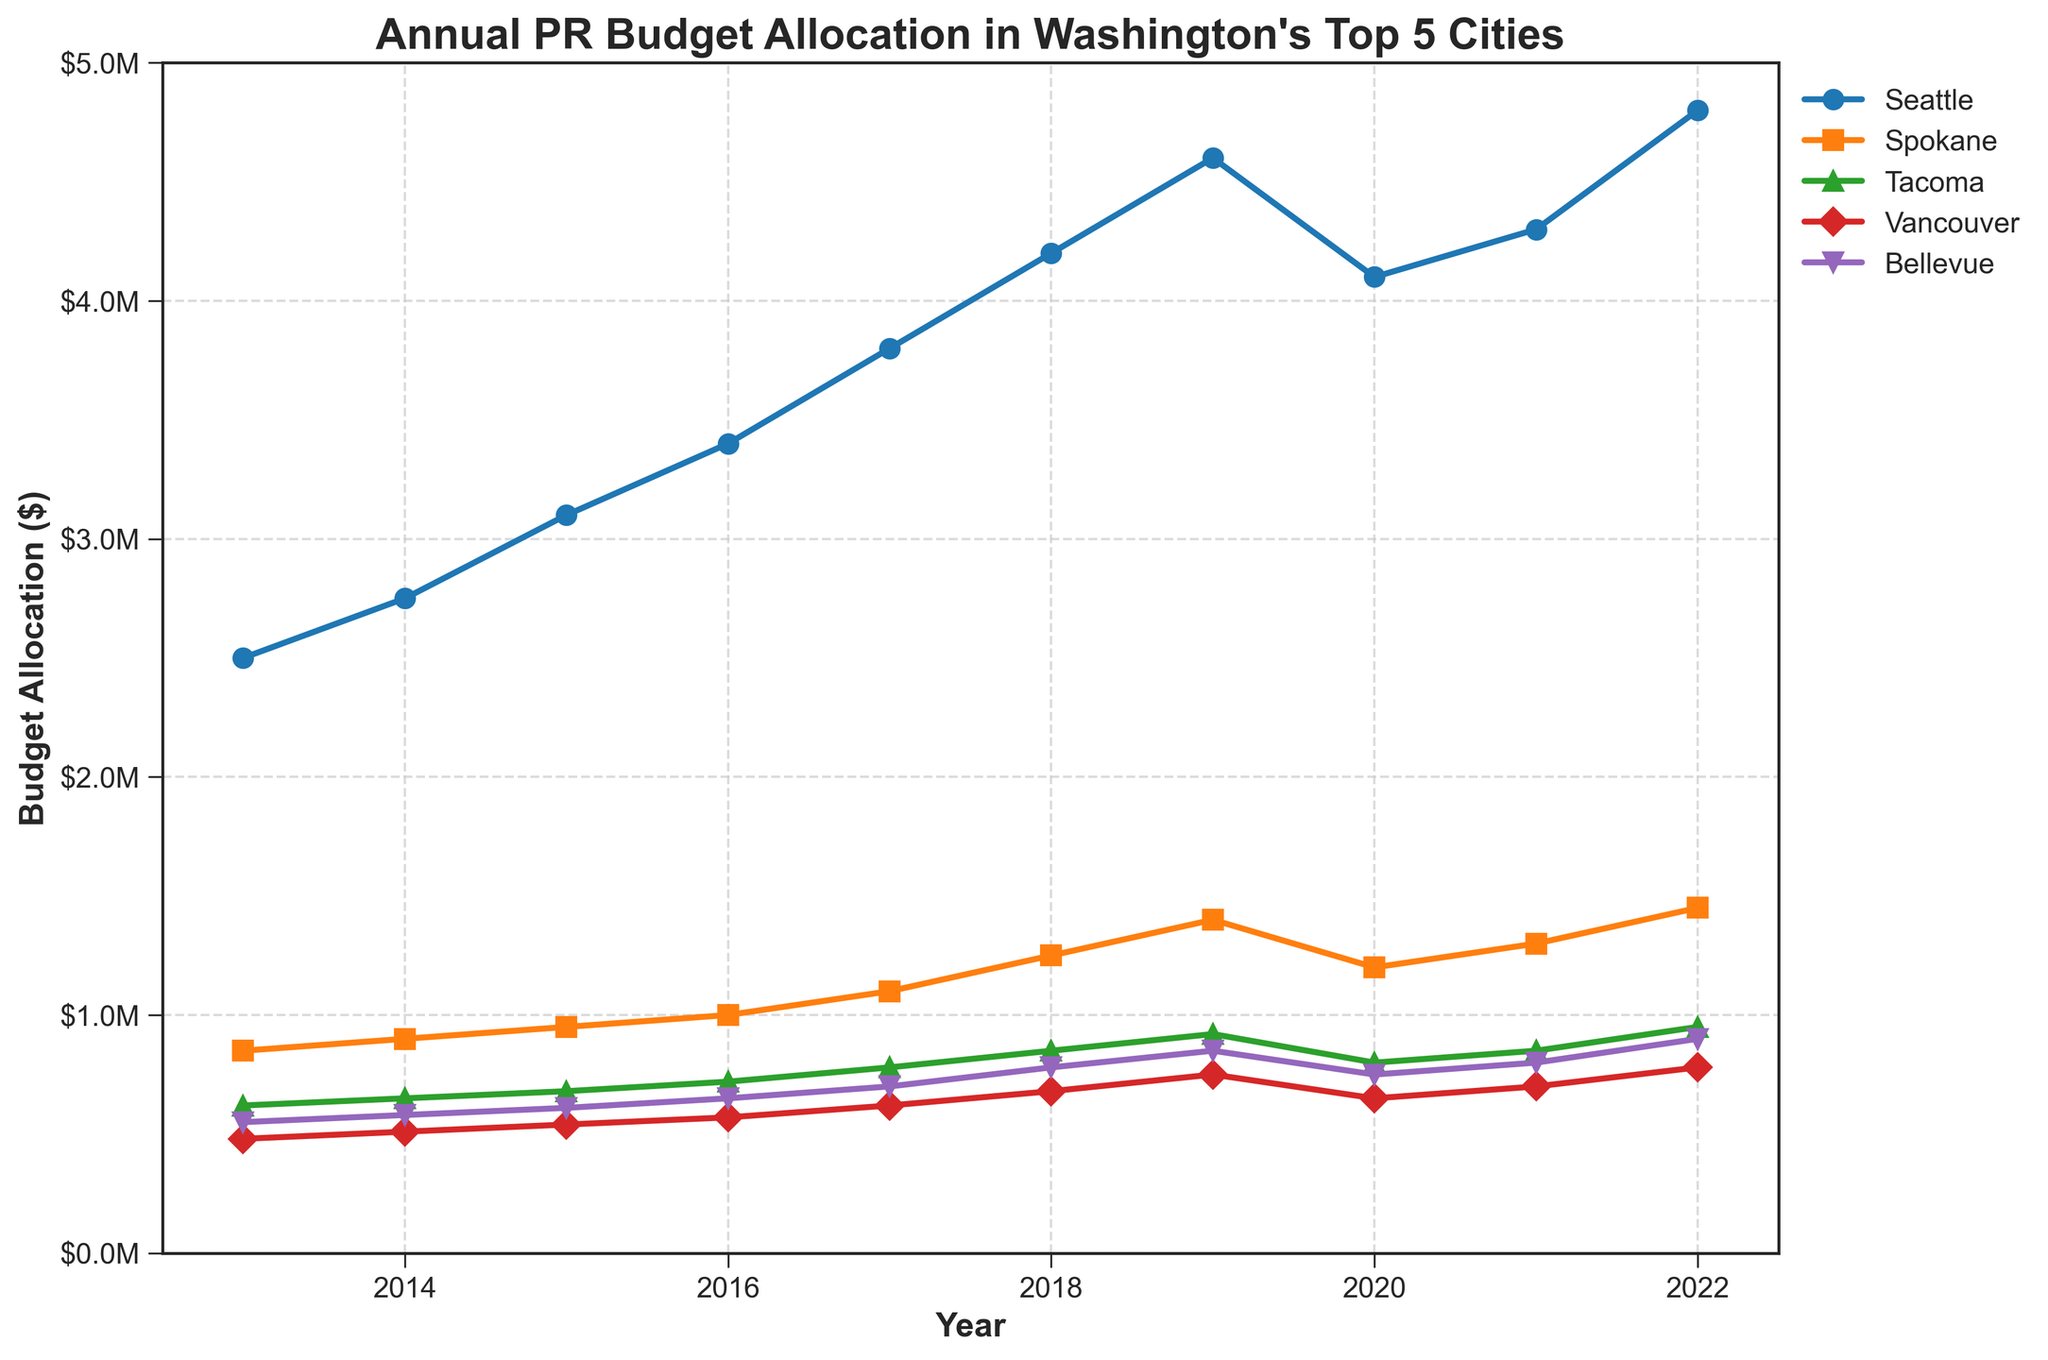What year did Seattle's budget allocation for public relations reach $3,100,000? Observing the graph, Seattle's budget crosses $3,100,000 in the year 2015, where the line for Seattle intersects the y-axis at $3,100,000.
Answer: 2015 Which city had the smallest budget allocation in 2013, and what was the amount? Looking at the individual lines on the graph for the year 2013, Vancouver has the smallest allocation, which is $480,000.
Answer: Vancouver, $480,000 During which year did Bellevue see the highest increase in budget allocation compared to the previous year? By checking the differences year-over-year for Bellevue: 2013-2014 (+$30,000), 2014-2015 (+$30,000), 2015-2016 (+$40,000), 2016-2017 (+$50,000), 2017-2018 (+$80,000), 2018-2019 (+$70,000), 2019-2020 (-$100,000), 2020-2021 (+$50,000), 2021-2022 (+$100,000). The highest increase is between 2021 and 2022 with $100,000.
Answer: 2021-2022 How did Spokane's budget allocation in 2020 compare to its allocation in 2019? By examining Spokane’s line, we see that it drops from $1,400,000 in 2019 to $1,200,000 in 2020. This is a decrease.
Answer: Decreased What is the average budget allocation for Tacoma over the entire decade? Summing up Tacoma’s budget for each year: 620,000 + 650,000 + 680,000 + 720,000 + 780,000 + 850,000 + 920,000 + 800,000 + 850,000 + 950,000 = 7,820,000. Dividing by 10 (number of years), the average is $782,000.
Answer: $782,000 Which city had the most consistent budget increase over the years based on the visual trendlines? A consistent increase means the line is steadily rising with few fluctuations. Seattle's line shows the most consistent upward trend over the years without drops, except a slight dip in 2020.
Answer: Seattle Between 2018 and 2019, which city had the highest absolute increase in budget allocation? By calculating the differences between 2018 and 2019 for each city: Seattle: $400,000, Spokane: $150,000, Tacoma: $70,000, Vancouver: $70,000, Bellevue: $70,000. Seattle has the highest increase.
Answer: Seattle In which year did Vancouver's budget allocation first reach $700,000? Inspecting the line for Vancouver, it first reaches $700,000 in the year 2021.
Answer: 2021 How much did Bellevue's budget allocation increase from 2013 to 2022? Bellevue's allocation in 2013 is $550,000, and in 2022 it is $900,000. The increase is 900,000 - 550,000 = $350,000.
Answer: $350,000 Which city shows the most significant drop in budget allocation in 2020 compared to the previous year? Comparing the differences for all cities between 2019 and 2020: Seattle (-500,000), Spokane (-200,000), Tacoma (-120,000), Vancouver (-100,000), Bellevue (-100,000). Seattle has the most significant drop.
Answer: Seattle 